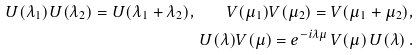<formula> <loc_0><loc_0><loc_500><loc_500>U ( \lambda _ { 1 } ) U ( \lambda _ { 2 } ) = U ( \lambda _ { 1 } + \lambda _ { 2 } ) , \quad V ( \mu _ { 1 } ) V ( \mu _ { 2 } ) = V ( \mu _ { 1 } + \mu _ { 2 } ) , \\ U ( \lambda ) V ( \mu ) = e ^ { - i \lambda \mu } \, V ( \mu ) \, U ( \lambda ) \, .</formula> 